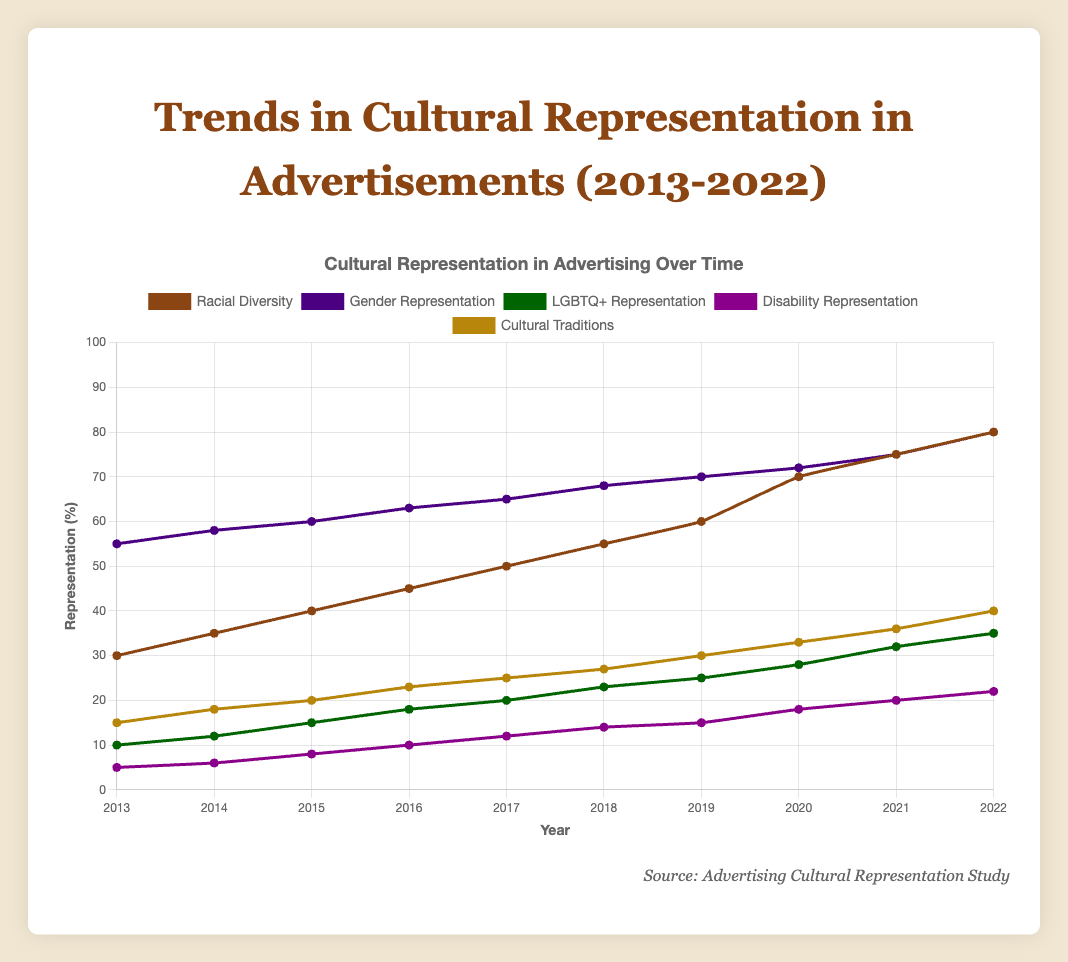Which category showed the highest increase in representation from 2013 to 2022? The "Racial Diversity" category increased from 30% in 2013 to 80% in 2022. Calculate the increase as 80 - 30 = 50 percentage points.
Answer: Racial Diversity How did the representation of "Gender Representation" change from 2014 to 2016? The representation in "Gender Representation" was 58% in 2014 and 63% in 2016. Subtract the earlier value from the later one: 63 - 58 = 5 percentage points increase.
Answer: Increased by 5 percentage points What is the trend of "LGBTQ+ Representation" over the decade? The data for "LGBTQ+ Representation" increases steadily every year from 10% in 2013 to 35% in 2022.
Answer: Increasing trend Compare the representation percentages of "Disability Representation" and "Cultural Traditions" in 2022. Which is higher? In 2022, the representation for "Disability Representation" is 22%, and for "Cultural Traditions" is 40%. Since 40 > 22, "Cultural Traditions" is higher.
Answer: Cultural Traditions What is the average increase per year in representation for "Racial Diversity"? The increase from 30% in 2013 to 80% in 2022 occurred over 9 intervals (2022-2013=9). The total increase is 50 percentage points, so the average per year is 50/9 ≈ 5.56 percentage points.
Answer: Approximately 5.56 percentage points per year Which category's representation was equal to "Gender Representation" in 2013 by the year 2020? "Gender Representation" was 55% in 2013. By looking at the year 2020, "Racial Diversity" reached 70%, which is the closest and higher.
Answer: No category, "Racial Diversity" was closest but higher Did any category show a decrease at any point over the decade? Reviewing the data, all categories showed a consistent increase every year from 2013 to 2022.
Answer: No What category had the smallest representation in 2015, and what was its value? The smallest representation in 2015 was "Disability Representation" at 8%.
Answer: Disability Representation, 8% By how much did "Cultural Traditions" representation grow from 2016 to 2020? The representation for "Cultural Traditions" was 23% in 2016 and 33% in 2020. Calculate the growth: 33 - 23 = 10 percentage points.
Answer: 10 percentage points What is the combined representation of "LGBTQ+ Representation" and "Disability Representation" in 2018? The representation percentages in 2018 are 23% for "LGBTQ+ Representation" and 14% for "Disability Representation". Combined, this is 23 + 14 = 37%.
Answer: 37% 